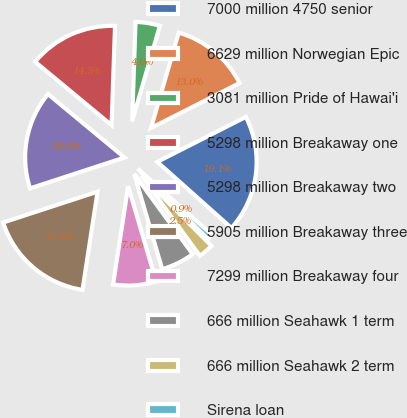Convert chart. <chart><loc_0><loc_0><loc_500><loc_500><pie_chart><fcel>7000 million 4750 senior<fcel>6629 million Norwegian Epic<fcel>3081 million Pride of Hawai'i<fcel>5298 million Breakaway one<fcel>5298 million Breakaway two<fcel>5905 million Breakaway three<fcel>7299 million Breakaway four<fcel>666 million Seahawk 1 term<fcel>666 million Seahawk 2 term<fcel>Sirena loan<nl><fcel>19.06%<fcel>13.02%<fcel>3.96%<fcel>14.53%<fcel>16.04%<fcel>17.55%<fcel>6.98%<fcel>5.47%<fcel>2.45%<fcel>0.94%<nl></chart> 